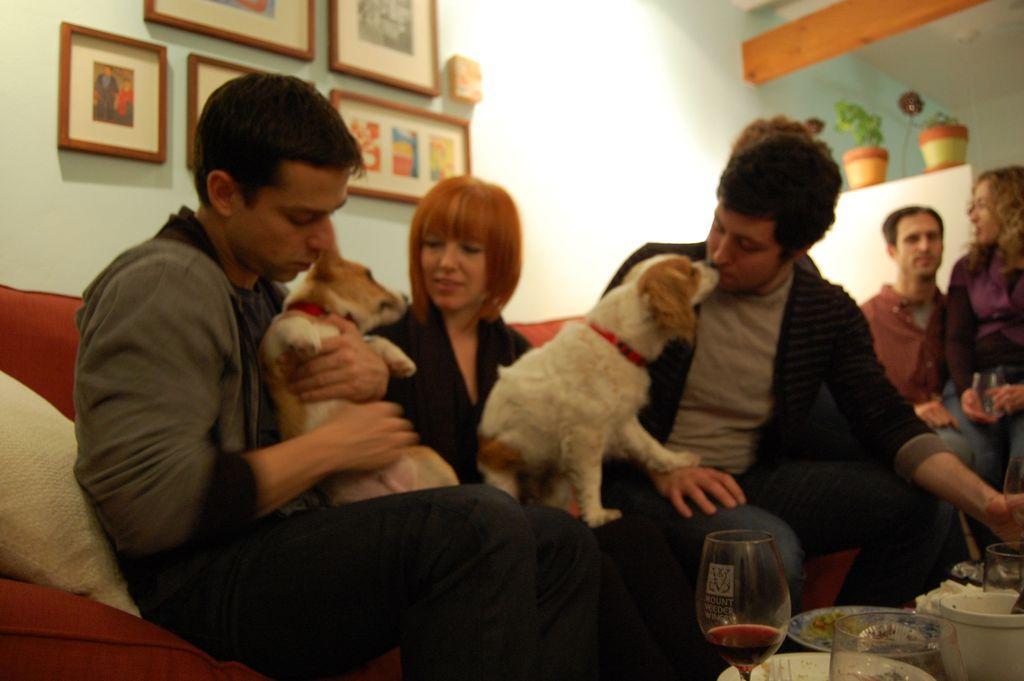Can you describe this image briefly? In this image person sitting at the left side is holding a dog. He is sitting in sofa. In the middle a woman is sitting in sofa by having a dog in her lap and another person sitting beside is kissing dog. Right Side there are two persons. Right side bottom there is a glass plate and a bowl. Few picture frames are attached to the wall. Pot with plants are behind the person. 